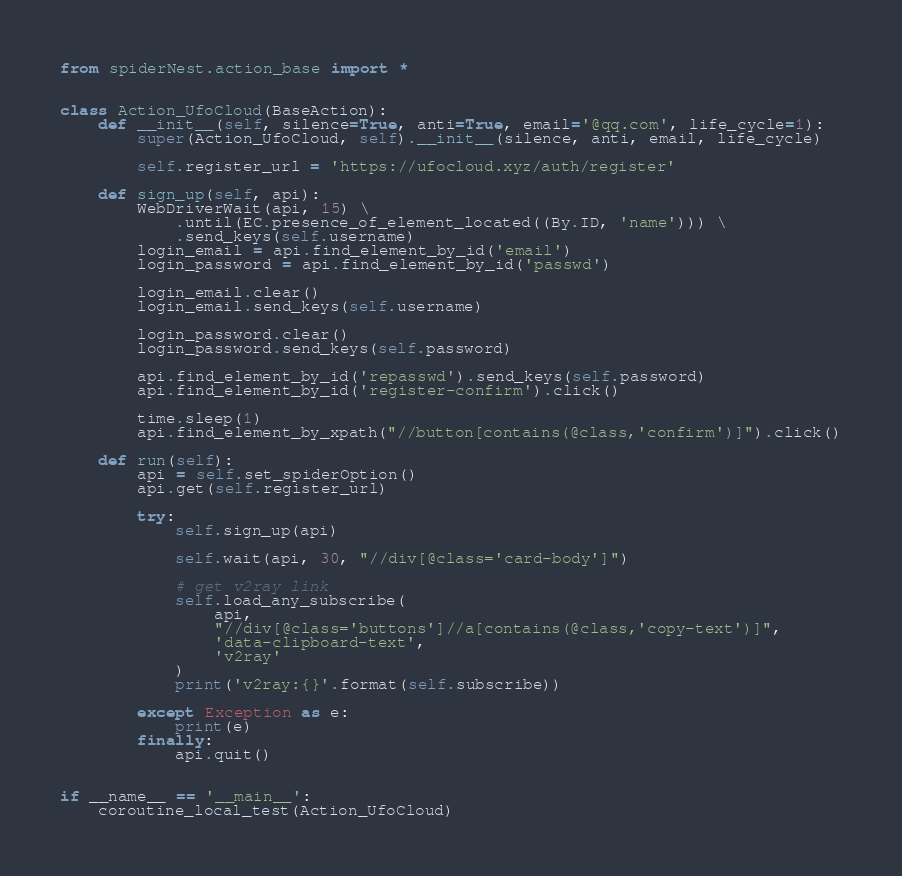<code> <loc_0><loc_0><loc_500><loc_500><_Python_>from spiderNest.action_base import *


class Action_UfoCloud(BaseAction):
    def __init__(self, silence=True, anti=True, email='@qq.com', life_cycle=1):
        super(Action_UfoCloud, self).__init__(silence, anti, email, life_cycle)

        self.register_url = 'https://ufocloud.xyz/auth/register'

    def sign_up(self, api):
        WebDriverWait(api, 15) \
            .until(EC.presence_of_element_located((By.ID, 'name'))) \
            .send_keys(self.username)
        login_email = api.find_element_by_id('email')
        login_password = api.find_element_by_id('passwd')

        login_email.clear()
        login_email.send_keys(self.username)

        login_password.clear()
        login_password.send_keys(self.password)

        api.find_element_by_id('repasswd').send_keys(self.password)
        api.find_element_by_id('register-confirm').click()

        time.sleep(1)
        api.find_element_by_xpath("//button[contains(@class,'confirm')]").click()

    def run(self):
        api = self.set_spiderOption()
        api.get(self.register_url)

        try:
            self.sign_up(api)

            self.wait(api, 30, "//div[@class='card-body']")

            # get v2ray link
            self.load_any_subscribe(
                api,
                "//div[@class='buttons']//a[contains(@class,'copy-text')]",
                'data-clipboard-text',
                'v2ray'
            )
            print('v2ray:{}'.format(self.subscribe))

        except Exception as e:
            print(e)
        finally:
            api.quit()


if __name__ == '__main__':
    coroutine_local_test(Action_UfoCloud)
</code> 